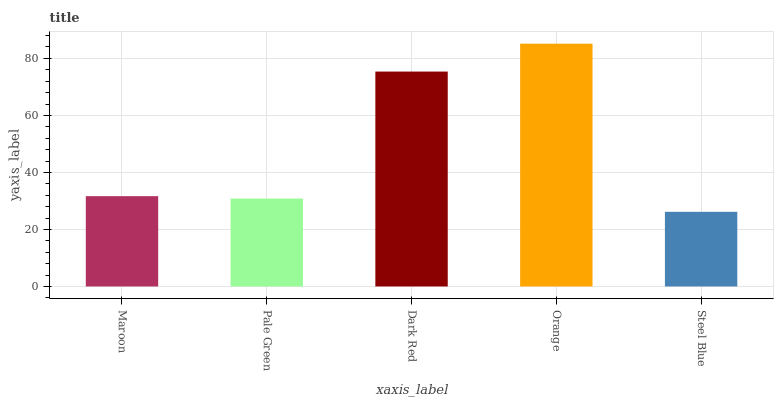Is Steel Blue the minimum?
Answer yes or no. Yes. Is Orange the maximum?
Answer yes or no. Yes. Is Pale Green the minimum?
Answer yes or no. No. Is Pale Green the maximum?
Answer yes or no. No. Is Maroon greater than Pale Green?
Answer yes or no. Yes. Is Pale Green less than Maroon?
Answer yes or no. Yes. Is Pale Green greater than Maroon?
Answer yes or no. No. Is Maroon less than Pale Green?
Answer yes or no. No. Is Maroon the high median?
Answer yes or no. Yes. Is Maroon the low median?
Answer yes or no. Yes. Is Dark Red the high median?
Answer yes or no. No. Is Orange the low median?
Answer yes or no. No. 